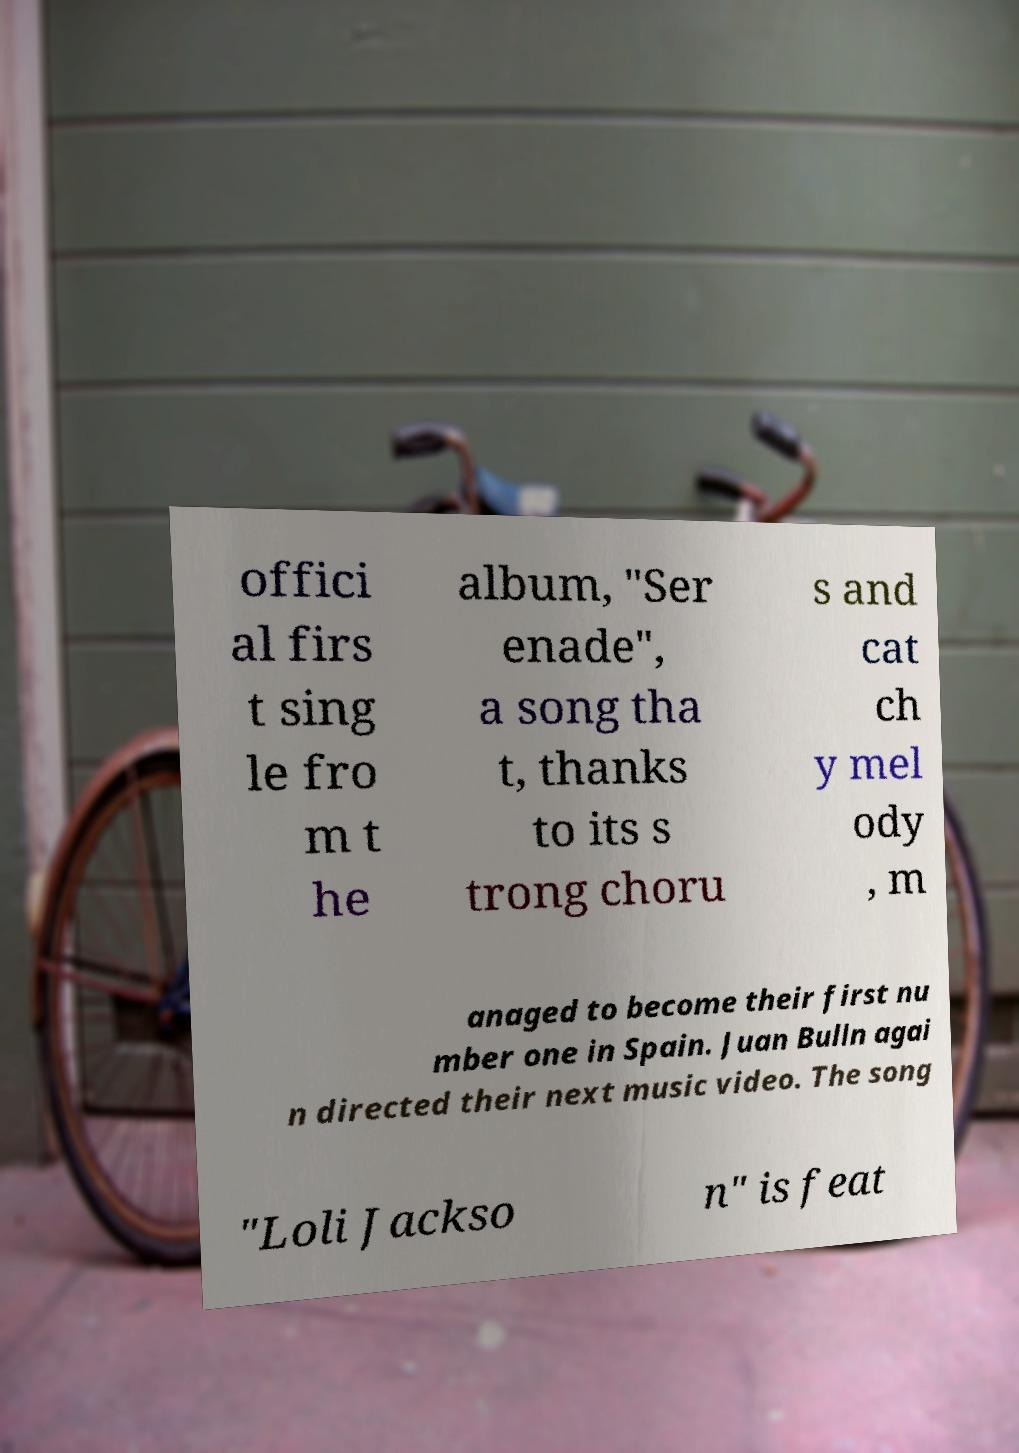For documentation purposes, I need the text within this image transcribed. Could you provide that? offici al firs t sing le fro m t he album, "Ser enade", a song tha t, thanks to its s trong choru s and cat ch y mel ody , m anaged to become their first nu mber one in Spain. Juan Bulln agai n directed their next music video. The song "Loli Jackso n" is feat 